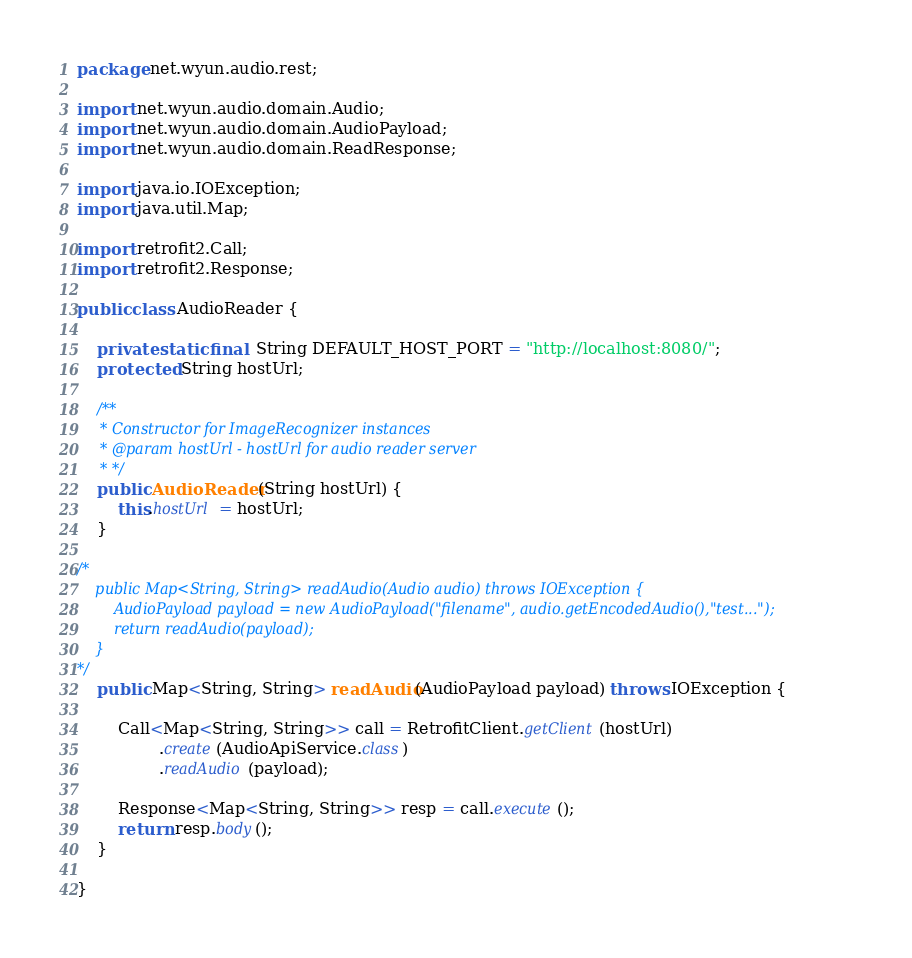<code> <loc_0><loc_0><loc_500><loc_500><_Java_>package net.wyun.audio.rest;

import net.wyun.audio.domain.Audio;
import net.wyun.audio.domain.AudioPayload;
import net.wyun.audio.domain.ReadResponse;

import java.io.IOException;
import java.util.Map;

import retrofit2.Call;
import retrofit2.Response;

public class AudioReader {

    private static final  String DEFAULT_HOST_PORT = "http://localhost:8080/";
    protected String hostUrl;

    /**
     * Constructor for ImageRecognizer instances
     * @param hostUrl - hostUrl for audio reader server
     * */
    public AudioReader(String hostUrl) {
        this.hostUrl = hostUrl;
    }

/*
    public Map<String, String> readAudio(Audio audio) throws IOException {
        AudioPayload payload = new AudioPayload("filename", audio.getEncodedAudio(),"test...");
        return readAudio(payload);
    }
*/
    public Map<String, String> readAudio(AudioPayload payload) throws IOException {

        Call<Map<String, String>> call = RetrofitClient.getClient(hostUrl)
                .create(AudioApiService.class)
                .readAudio(payload);

        Response<Map<String, String>> resp = call.execute();
        return resp.body();
    }

}
</code> 